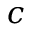Convert formula to latex. <formula><loc_0><loc_0><loc_500><loc_500>c</formula> 